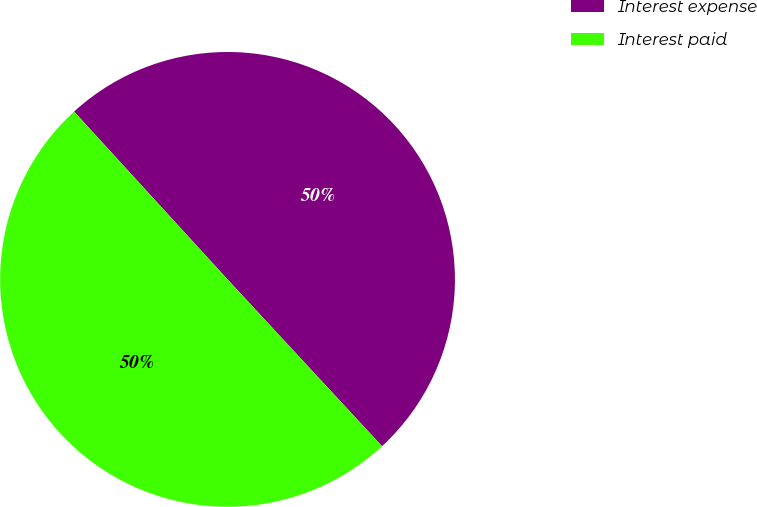Convert chart to OTSL. <chart><loc_0><loc_0><loc_500><loc_500><pie_chart><fcel>Interest expense<fcel>Interest paid<nl><fcel>49.9%<fcel>50.1%<nl></chart> 